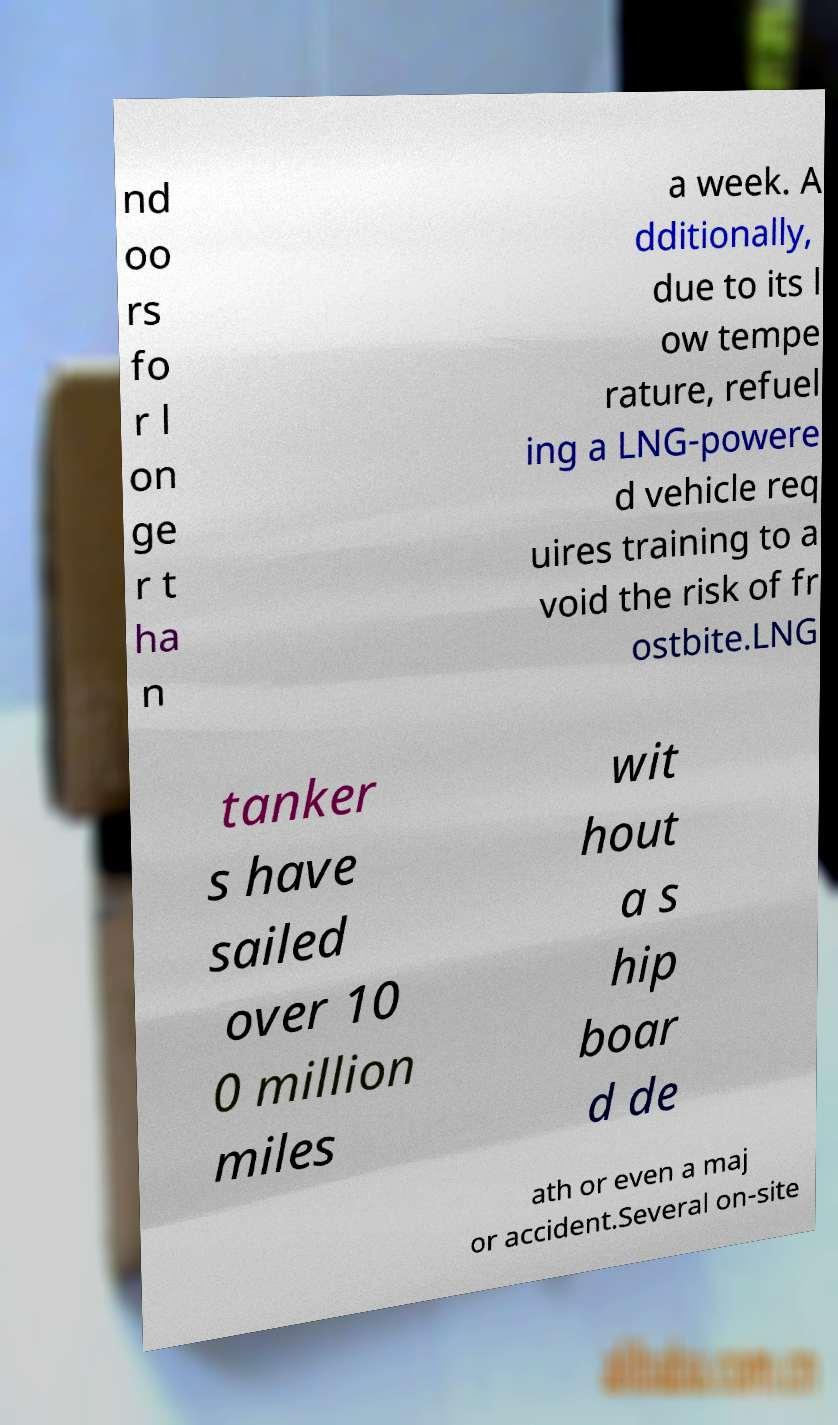Can you read and provide the text displayed in the image?This photo seems to have some interesting text. Can you extract and type it out for me? nd oo rs fo r l on ge r t ha n a week. A dditionally, due to its l ow tempe rature, refuel ing a LNG-powere d vehicle req uires training to a void the risk of fr ostbite.LNG tanker s have sailed over 10 0 million miles wit hout a s hip boar d de ath or even a maj or accident.Several on-site 